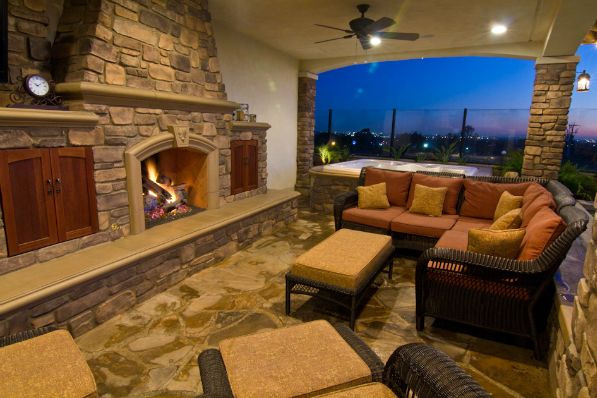How many people are in the room? 0 